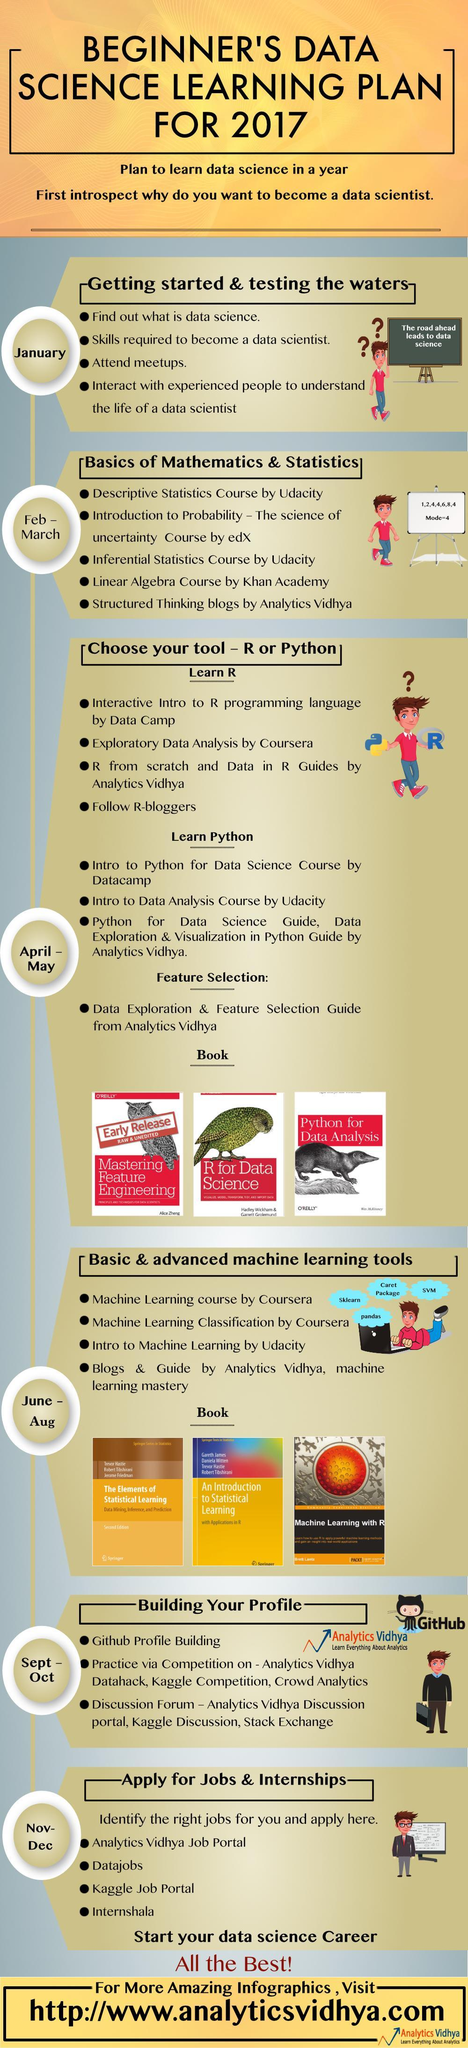Who is the publisher of the Data Science books ?
Answer the question with a short phrase. O'REILLY How many courses are offered in Statistics by Udacity? 2 Which programming languages are used in Data Science? R, Python Which step of the beginner's data science learning plan is to be taken during the month of September to October ? Building Your Profile 